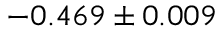<formula> <loc_0><loc_0><loc_500><loc_500>- 0 . 4 6 9 \pm 0 . 0 0 9</formula> 